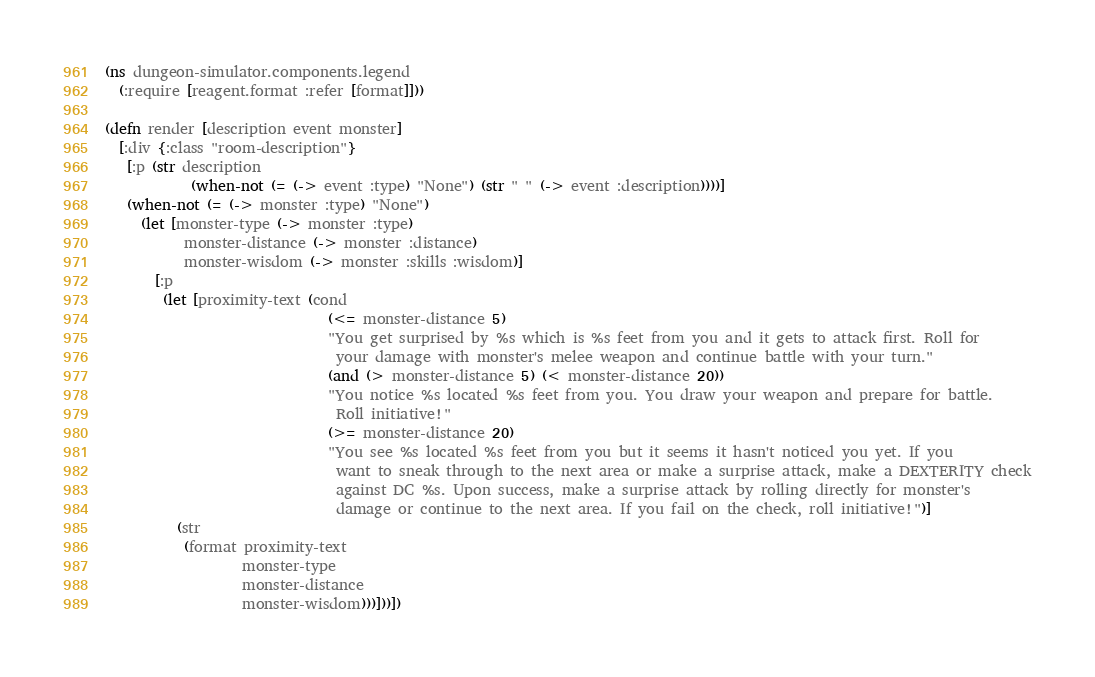<code> <loc_0><loc_0><loc_500><loc_500><_Clojure_>(ns dungeon-simulator.components.legend
  (:require [reagent.format :refer [format]]))

(defn render [description event monster]
  [:div {:class "room-description"}
   [:p (str description
            (when-not (= (-> event :type) "None") (str " " (-> event :description))))]
   (when-not (= (-> monster :type) "None")
     (let [monster-type (-> monster :type)
           monster-distance (-> monster :distance)
           monster-wisdom (-> monster :skills :wisdom)]
       [:p
        (let [proximity-text (cond
                               (<= monster-distance 5)
                               "You get surprised by %s which is %s feet from you and it gets to attack first. Roll for
                                your damage with monster's melee weapon and continue battle with your turn."
                               (and (> monster-distance 5) (< monster-distance 20))
                               "You notice %s located %s feet from you. You draw your weapon and prepare for battle.
                                Roll initiative!"
                               (>= monster-distance 20)
                               "You see %s located %s feet from you but it seems it hasn't noticed you yet. If you
                                want to sneak through to the next area or make a surprise attack, make a DEXTERITY check
                                against DC %s. Upon success, make a surprise attack by rolling directly for monster's
                                damage or continue to the next area. If you fail on the check, roll initiative!")]
          (str
           (format proximity-text
                   monster-type
                   monster-distance
                   monster-wisdom)))]))])
</code> 